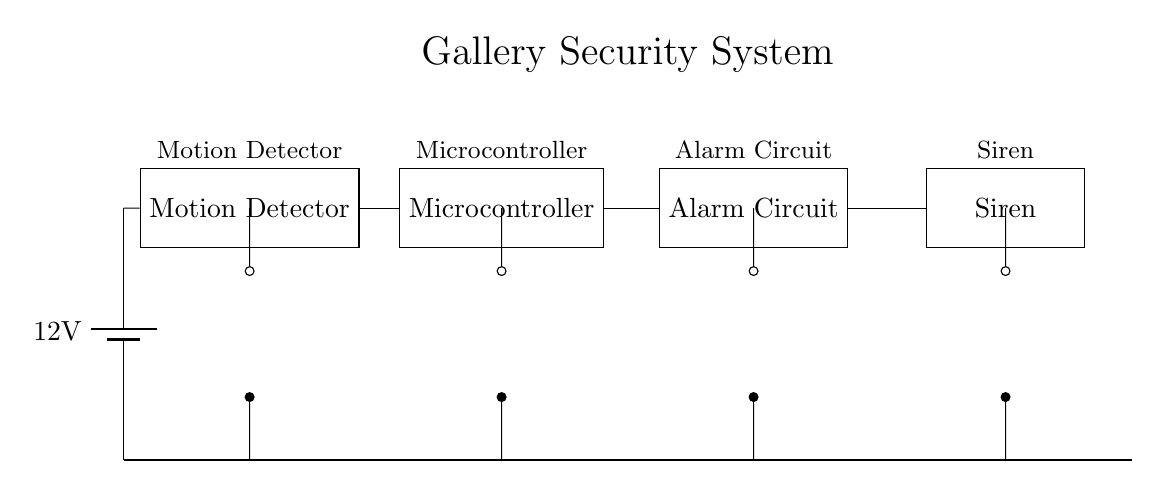What is the voltage of this circuit? The voltage is 12 volts, which is specified at the battery connected to the circuit.
Answer: 12 volts What component detects movement? The component that detects movement is the Motion Detector, as labeled in the circuit.
Answer: Motion Detector Which component triggers the alarm? The component that triggers the alarm is the Alarm Circuit, which is connected to the Microcontroller.
Answer: Alarm Circuit How many devices are powered by the circuit? There are four devices powered by the circuit: the Motion Detector, Microcontroller, Alarm Circuit, and Siren.
Answer: Four What is the primary function of the Microcontroller? The primary function of the Microcontroller is to process the signals from the Motion Detector and activate the Alarm Circuit as needed.
Answer: Process signals What happens to the system when motion is detected? When motion is detected, the Motion Detector sends a signal to the Microcontroller, which then activates the Alarm Circuit to trigger the Siren.
Answer: Alarm is triggered What is the purpose of the Siren in this system? The purpose of the Siren is to provide an audible alert when the Alarm Circuit is activated, indicating a security breach.
Answer: Audible alert 